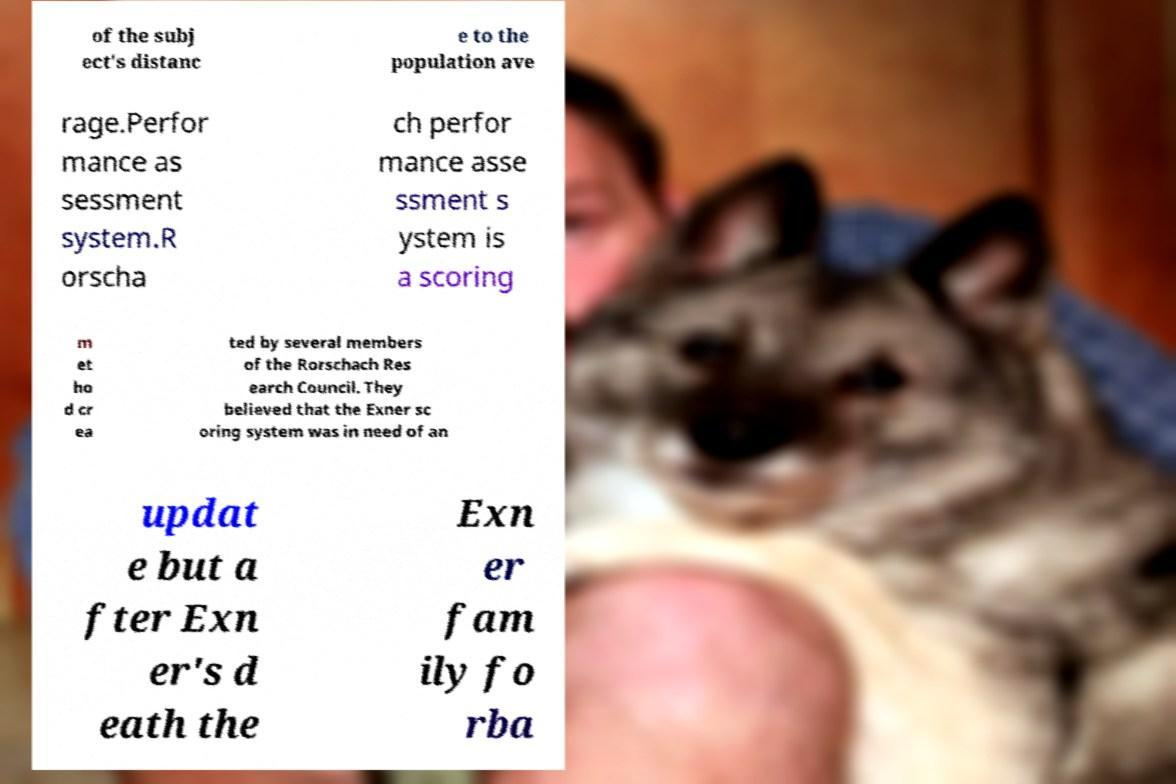What messages or text are displayed in this image? I need them in a readable, typed format. of the subj ect's distanc e to the population ave rage.Perfor mance as sessment system.R orscha ch perfor mance asse ssment s ystem is a scoring m et ho d cr ea ted by several members of the Rorschach Res earch Council. They believed that the Exner sc oring system was in need of an updat e but a fter Exn er's d eath the Exn er fam ily fo rba 